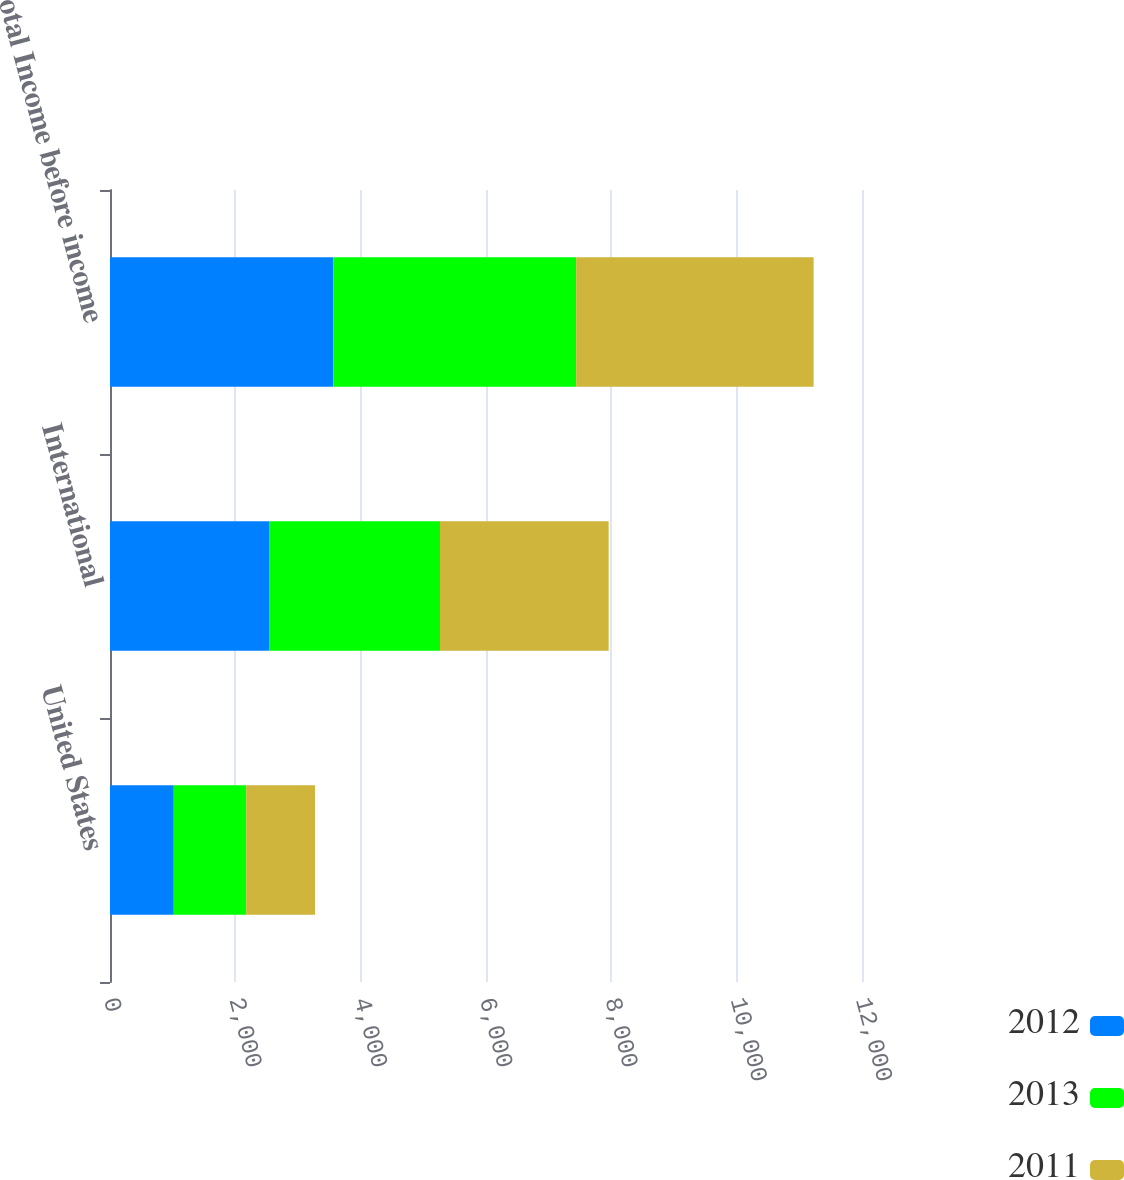<chart> <loc_0><loc_0><loc_500><loc_500><stacked_bar_chart><ecel><fcel>United States<fcel>International<fcel>Total Income before income<nl><fcel>2012<fcel>1018<fcel>2547<fcel>3565<nl><fcel>2013<fcel>1155<fcel>2719<fcel>3874<nl><fcel>2011<fcel>1098<fcel>2691<fcel>3789<nl></chart> 